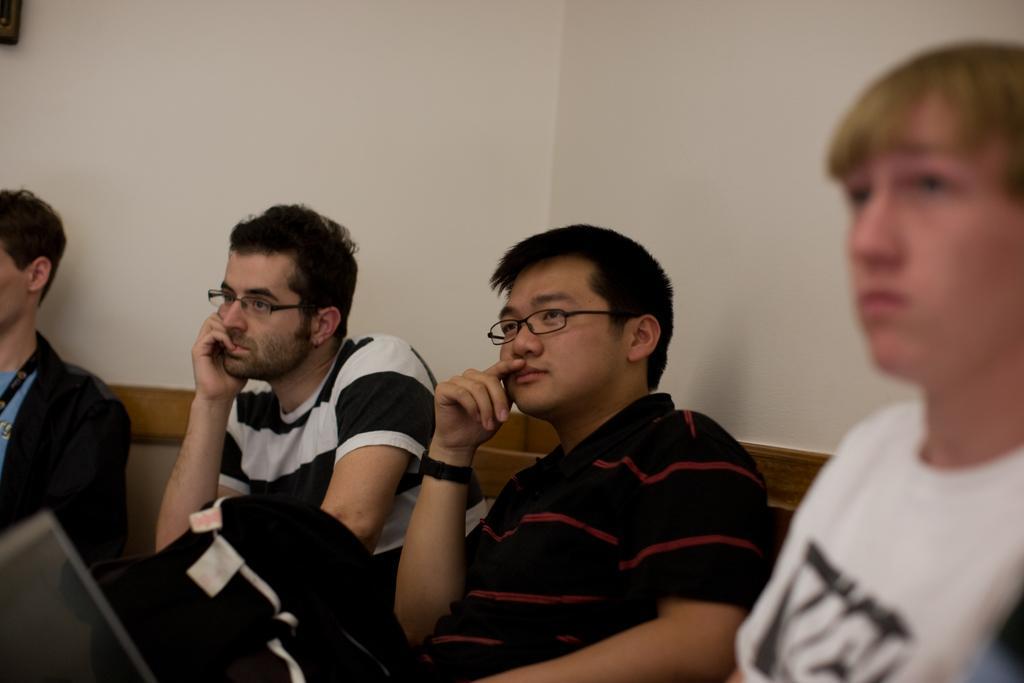Could you give a brief overview of what you see in this image? In this image we can see people sitting. In the background there is a wall and we can see clothes. 